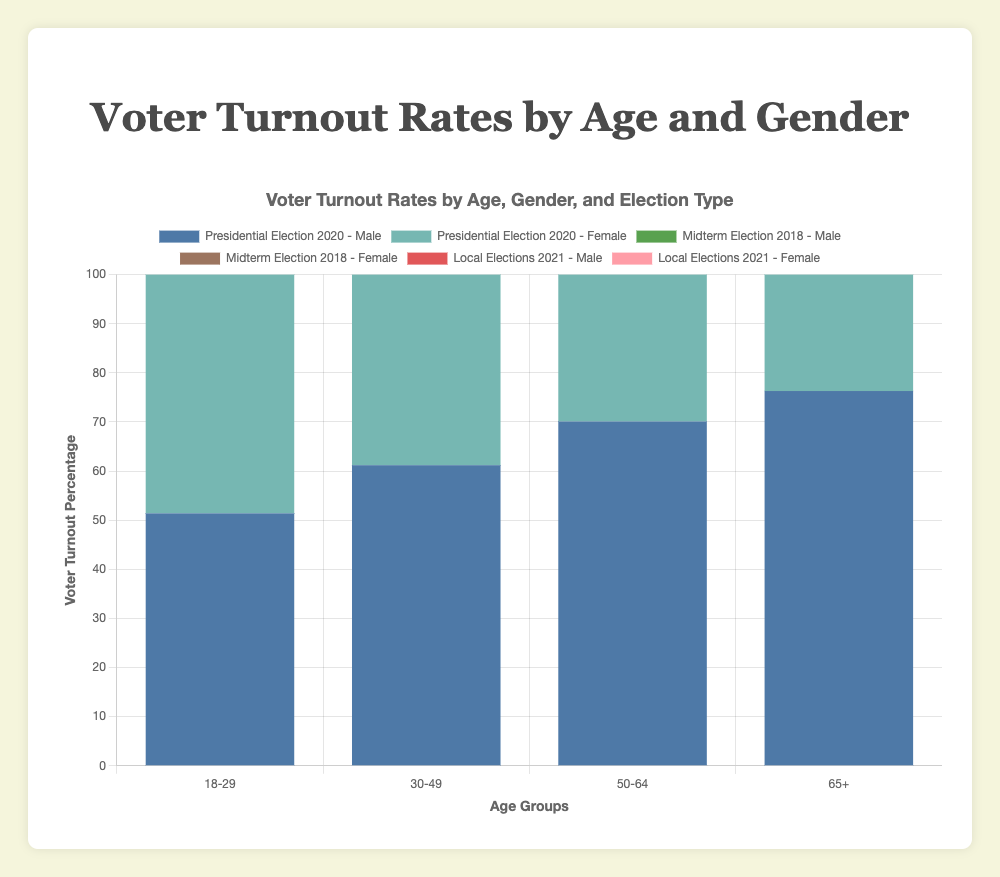What is the voter turnout percentage for females aged 18-29 in the Presidential Election 2020? To find this, we need to look at the Presidential Election 2020 section of the chart, locate the 18-29 age group, and identify the percentage for females. This value is depicted as a certain height/color bar assigned to females.
Answer: 55.4% Which age group had the highest voter turnout percentage in the Midterm Election 2018? To answer this, we examine the bars for each age group represented in the Midterm Election 2018. The age group with the highest stack of percentages between males and females will be our answer.
Answer: 65+ age group Compare the voter turnout percentages of males and females aged 30-49 in Local Elections 2021. Which gender had a higher turnout? Look at the specific bars for the 30-49 age group in the Local Elections 2021. Compare the heights/colors of the male and female bars to determine which one is higher.
Answer: Females What is the difference in voter turnout between males aged 50-64 in the Midterm Election 2018 and the Presidential Election 2020? First, locate the voter turnout percentage for males aged 50-64 in both the Midterm Election 2018 (58.1%) and Presidential Election 2020 (70.1%). Then, subtract the midterm percentage from the presidential percentage. (70.1 - 58.1 = 12.0)
Answer: 12.0% What is the average voter turnout percentage for the 18-29 age group across all elections? Identify the voter turnout percentages for the 18-29 age group in all three elections: 51.4% and 55.4% (Presidential 2020), 30.1% and 35.3% (Midterm 2018), 21.9% and 24.7% (Local 2021). Sum these values and divide by the number of percentages. [(51.4 + 55.4 + 30.1 + 35.3 + 21.9 + 24.7) / 6 = 36.47]
Answer: 36.47% Compare the voter turnout percentage for males aged 65+ in Presidential Election 2020 with females aged 65+ in Local Elections 2021. Which group had a higher turnout? Identify the voter turnout percentages for males aged 65+ in the Presidential Election 2020 (76.3%) and for females aged 65+ in Local Elections 2021 (55.7%). Compare these two values to see which is higher.
Answer: Males aged 65+ in Presidential Election 2020 What is the total voter turnout percentage for males across all age groups in the Presidential Election 2020? Sum up the voter turnout percentages for males in all age groups in the Presidential Election 2020. (51.4 + 61.2 + 70.1 + 76.3).
Answer: 259.0% 